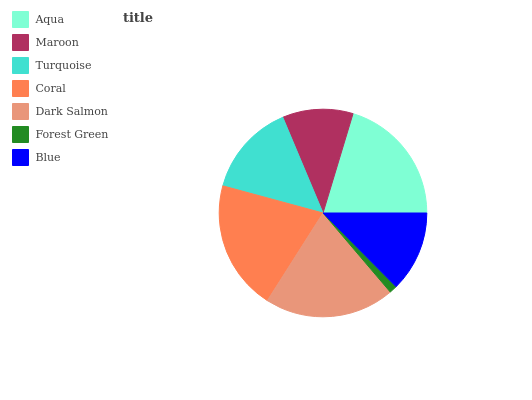Is Forest Green the minimum?
Answer yes or no. Yes. Is Aqua the maximum?
Answer yes or no. Yes. Is Maroon the minimum?
Answer yes or no. No. Is Maroon the maximum?
Answer yes or no. No. Is Aqua greater than Maroon?
Answer yes or no. Yes. Is Maroon less than Aqua?
Answer yes or no. Yes. Is Maroon greater than Aqua?
Answer yes or no. No. Is Aqua less than Maroon?
Answer yes or no. No. Is Turquoise the high median?
Answer yes or no. Yes. Is Turquoise the low median?
Answer yes or no. Yes. Is Maroon the high median?
Answer yes or no. No. Is Forest Green the low median?
Answer yes or no. No. 